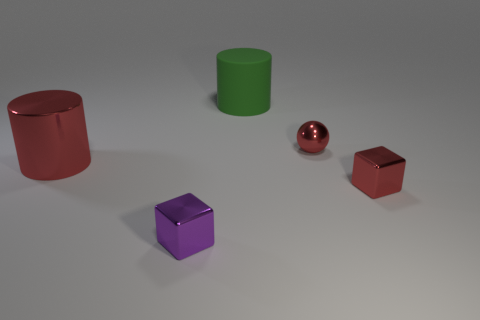Does the metal cube right of the small red metallic sphere have the same color as the cylinder behind the large metallic cylinder?
Provide a short and direct response. No. What number of other objects are there of the same shape as the tiny purple object?
Offer a very short reply. 1. Is the number of red cylinders that are to the right of the tiny purple metallic cube the same as the number of rubber cylinders to the right of the tiny red cube?
Your response must be concise. Yes. Is the material of the big cylinder that is right of the purple block the same as the tiny cube right of the small purple block?
Provide a succinct answer. No. What number of other objects are there of the same size as the green rubber cylinder?
Ensure brevity in your answer.  1. How many things are either large spheres or tiny things to the left of the red cube?
Offer a very short reply. 2. Is the number of purple blocks behind the big rubber thing the same as the number of small yellow metal cylinders?
Your response must be concise. Yes. What is the shape of the small purple thing that is the same material as the red cube?
Provide a short and direct response. Cube. Is there a metallic cylinder that has the same color as the small metal ball?
Keep it short and to the point. Yes. What number of metallic things are red objects or small yellow cylinders?
Provide a short and direct response. 3. 